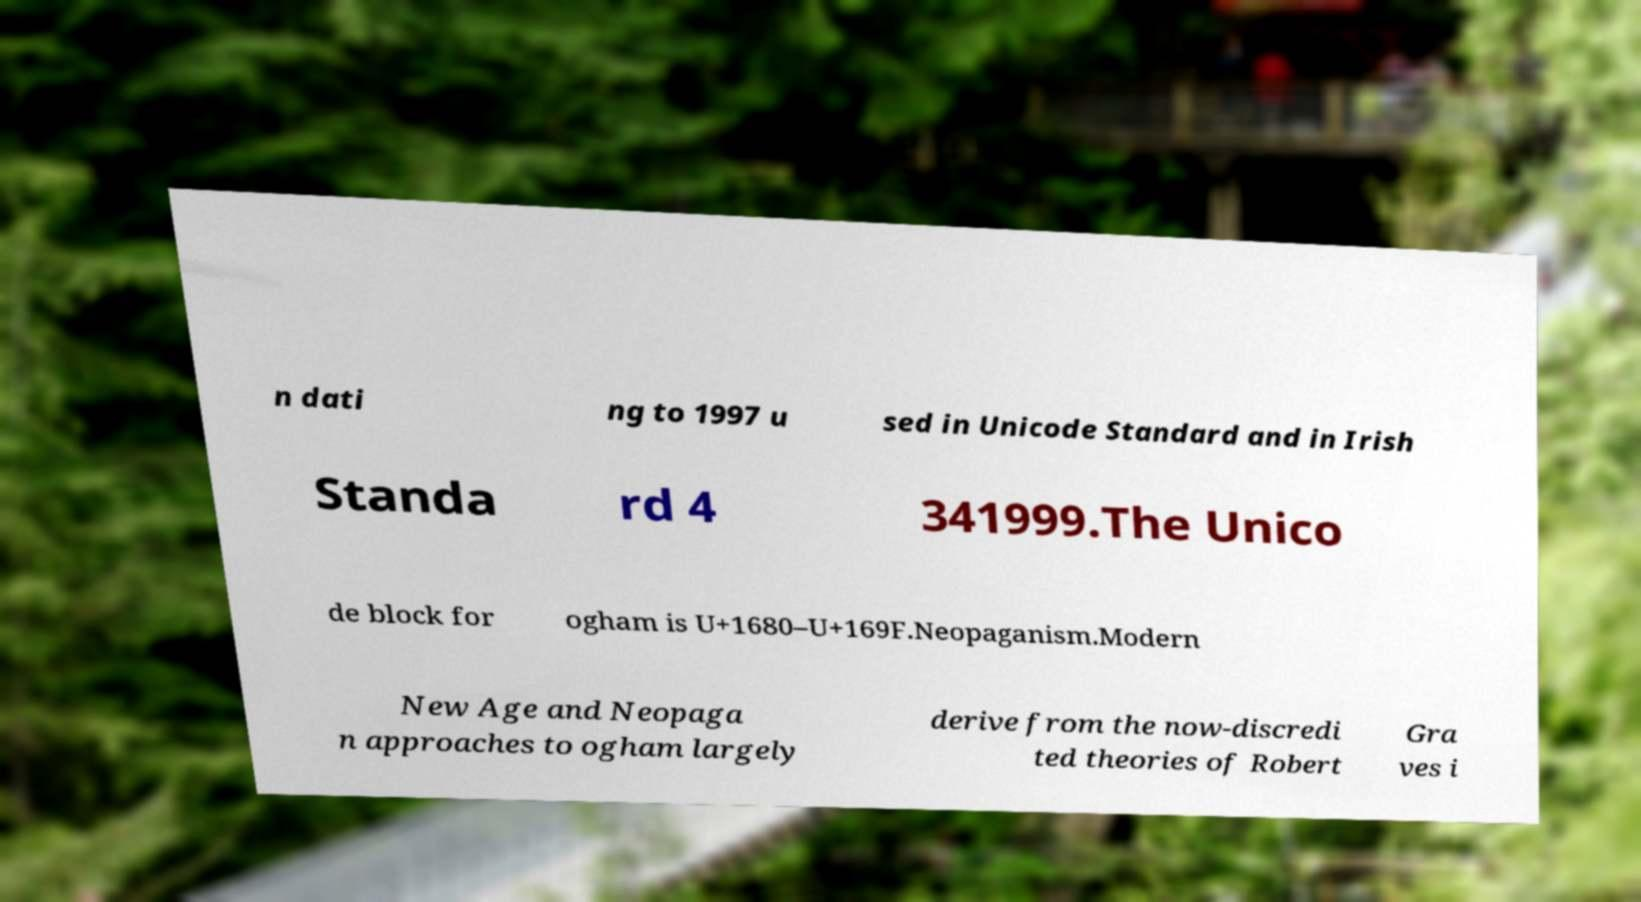Can you accurately transcribe the text from the provided image for me? n dati ng to 1997 u sed in Unicode Standard and in Irish Standa rd 4 341999.The Unico de block for ogham is U+1680–U+169F.Neopaganism.Modern New Age and Neopaga n approaches to ogham largely derive from the now-discredi ted theories of Robert Gra ves i 